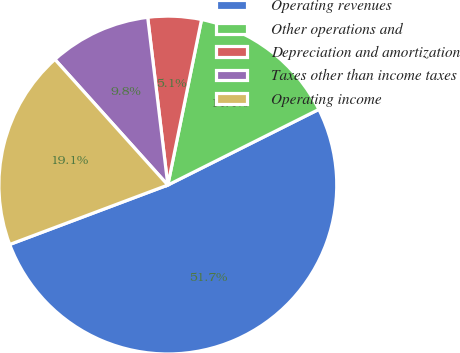<chart> <loc_0><loc_0><loc_500><loc_500><pie_chart><fcel>Operating revenues<fcel>Other operations and<fcel>Depreciation and amortization<fcel>Taxes other than income taxes<fcel>Operating income<nl><fcel>51.67%<fcel>14.41%<fcel>5.1%<fcel>9.75%<fcel>19.07%<nl></chart> 